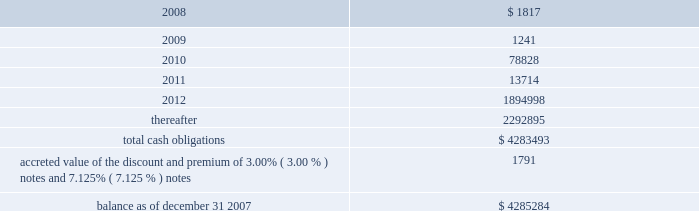American tower corporation and subsidiaries notes to consolidated financial statements 2014 ( continued ) maturities 2014as of december 31 , 2007 , aggregate carrying value of long-term debt , including capital leases , for the next five years and thereafter are estimated to be ( in thousands ) : year ending december 31 .
Acquisitions during the years ended december 31 , 2007 , 2006 and 2005 , the company used cash to acquire a total of ( i ) 293 towers and the assets of a structural analysis firm for approximately $ 44.0 million in cash ( ii ) 84 towers and 6 in-building distributed antenna systems for approximately $ 14.3 million and ( iii ) 30 towers for approximately $ 6.0 million in cash , respectively .
The tower asset acquisitions were primarily in mexico and brazil under ongoing agreements .
During the year ended december 31 , 2005 , the company also completed its merger with spectrasite , inc .
Pursuant to which the company acquired approximately 7800 towers and 100 in-building distributed antenna systems .
Under the terms of the merger agreement , in august 2005 , spectrasite , inc .
Merged with a wholly- owned subsidiary of the company , and each share of spectrasite , inc .
Common stock converted into the right to receive 3.575 shares of the company 2019s class a common stock .
The company issued approximately 169.5 million shares of its class a common stock and reserved for issuance approximately 9.9 million and 6.8 million of class a common stock pursuant to spectrasite , inc .
Options and warrants , respectively , assumed in the merger .
The final allocation of the $ 3.1 billion purchase price is summarized in the company 2019s annual report on form 10-k for the year ended december 31 , 2006 .
The acquisitions consummated by the company during 2007 , 2006 and 2005 , have been accounted for under the purchase method of accounting in accordance with sfas no .
141 201cbusiness combinations 201d ( sfas no .
141 ) .
The purchase prices have been allocated to the net assets acquired and the liabilities assumed based on their estimated fair values at the date of acquisition .
The company primarily acquired its tower assets from third parties in one of two types of transactions : the purchase of a business or the purchase of assets .
The structure of each transaction affects the way the company allocates purchase price within the consolidated financial statements .
In the case of tower assets acquired through the purchase of a business , such as the company 2019s merger with spectrasite , inc. , the company allocates the purchase price to the assets acquired and liabilities assumed at their estimated fair values as of the date of acquisition .
The excess of the purchase price paid by the company over the estimated fair value of net assets acquired has been recorded as goodwill .
In the case of an asset purchase , the company first allocates the purchase price to property and equipment for the appraised value of the towers and to identifiable intangible assets ( primarily acquired customer base ) .
The company then records any remaining purchase price within intangible assets as a 201cnetwork location intangible . 201d .
Based solely on cash for towers acquisitions , what was the average cost per tower acquired in 2005-2007? 
Computations: ((6.0 * 1000000) / 30)
Answer: 200000.0. American tower corporation and subsidiaries notes to consolidated financial statements 2014 ( continued ) maturities 2014as of december 31 , 2007 , aggregate carrying value of long-term debt , including capital leases , for the next five years and thereafter are estimated to be ( in thousands ) : year ending december 31 .
Acquisitions during the years ended december 31 , 2007 , 2006 and 2005 , the company used cash to acquire a total of ( i ) 293 towers and the assets of a structural analysis firm for approximately $ 44.0 million in cash ( ii ) 84 towers and 6 in-building distributed antenna systems for approximately $ 14.3 million and ( iii ) 30 towers for approximately $ 6.0 million in cash , respectively .
The tower asset acquisitions were primarily in mexico and brazil under ongoing agreements .
During the year ended december 31 , 2005 , the company also completed its merger with spectrasite , inc .
Pursuant to which the company acquired approximately 7800 towers and 100 in-building distributed antenna systems .
Under the terms of the merger agreement , in august 2005 , spectrasite , inc .
Merged with a wholly- owned subsidiary of the company , and each share of spectrasite , inc .
Common stock converted into the right to receive 3.575 shares of the company 2019s class a common stock .
The company issued approximately 169.5 million shares of its class a common stock and reserved for issuance approximately 9.9 million and 6.8 million of class a common stock pursuant to spectrasite , inc .
Options and warrants , respectively , assumed in the merger .
The final allocation of the $ 3.1 billion purchase price is summarized in the company 2019s annual report on form 10-k for the year ended december 31 , 2006 .
The acquisitions consummated by the company during 2007 , 2006 and 2005 , have been accounted for under the purchase method of accounting in accordance with sfas no .
141 201cbusiness combinations 201d ( sfas no .
141 ) .
The purchase prices have been allocated to the net assets acquired and the liabilities assumed based on their estimated fair values at the date of acquisition .
The company primarily acquired its tower assets from third parties in one of two types of transactions : the purchase of a business or the purchase of assets .
The structure of each transaction affects the way the company allocates purchase price within the consolidated financial statements .
In the case of tower assets acquired through the purchase of a business , such as the company 2019s merger with spectrasite , inc. , the company allocates the purchase price to the assets acquired and liabilities assumed at their estimated fair values as of the date of acquisition .
The excess of the purchase price paid by the company over the estimated fair value of net assets acquired has been recorded as goodwill .
In the case of an asset purchase , the company first allocates the purchase price to property and equipment for the appraised value of the towers and to identifiable intangible assets ( primarily acquired customer base ) .
The company then records any remaining purchase price within intangible assets as a 201cnetwork location intangible . 201d .
What is the total number of towers acquired in the last three years? 
Computations: ((293 + 84) + 30)
Answer: 407.0. 